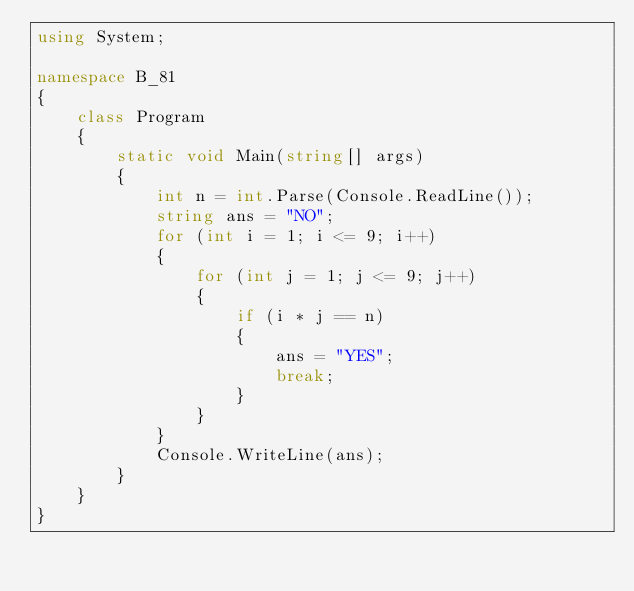Convert code to text. <code><loc_0><loc_0><loc_500><loc_500><_C#_>using System;

namespace B_81
{
    class Program
    {
        static void Main(string[] args)
        {
            int n = int.Parse(Console.ReadLine());
            string ans = "NO";
            for (int i = 1; i <= 9; i++)
            {
                for (int j = 1; j <= 9; j++)
                {
                    if (i * j == n)
                    {
                        ans = "YES";
                        break;
                    }
                }
            }
            Console.WriteLine(ans);
        }
    }
}
</code> 